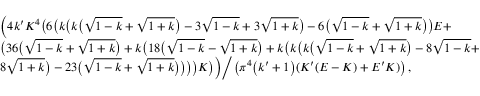<formula> <loc_0><loc_0><loc_500><loc_500>\begin{array} { r l } & { \left ( 4 k ^ { \prime } K ^ { 4 } \left ( 6 \left ( k \left ( k \left ( \sqrt { 1 - k } + \sqrt { 1 + k } \right ) - 3 \sqrt { 1 - k } + 3 \sqrt { 1 + k } \right ) - 6 \left ( \sqrt { 1 - k } + \sqrt { 1 + k } \right ) \right ) E + } \\ & { \left ( 3 6 \left ( \sqrt { 1 - k } + \sqrt { 1 + k } \right ) + k \left ( 1 8 \left ( \sqrt { 1 - k } - \sqrt { 1 + k } \right ) + k \left ( k \left ( k \left ( \sqrt { 1 - k } + \sqrt { 1 + k } \right ) - 8 \sqrt { 1 - k } + } \\ & { 8 \sqrt { 1 + k } \right ) - 2 3 \left ( \sqrt { 1 - k } + \sqrt { 1 + k } \right ) \right ) \right ) \right ) K \right ) \right ) \Big / \left ( \pi ^ { 4 } \left ( k ^ { \prime } + 1 \right ) ( K ^ { \prime } ( E - K ) + E ^ { \prime } K ) \right ) , } \end{array}</formula> 